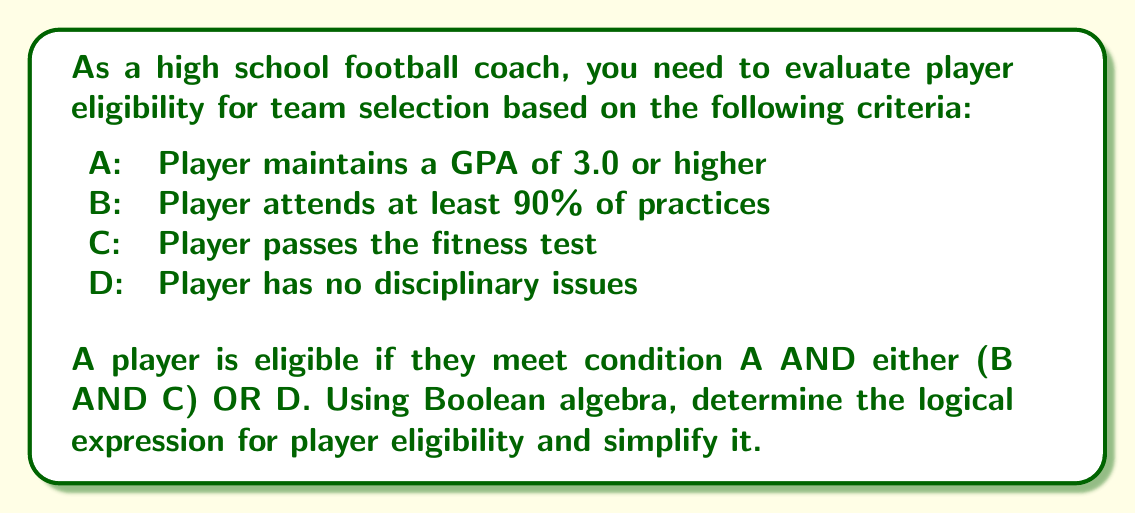Teach me how to tackle this problem. Let's approach this step-by-step:

1) First, let's write out the logical expression based on the given conditions:

   $E = A \wedge ((B \wedge C) \vee D)$

   Where E represents eligibility, and $\wedge$ means AND, $\vee$ means OR.

2) To simplify this expression, we can use the distributive law of Boolean algebra:

   $X \wedge (Y \vee Z) = (X \wedge Y) \vee (X \wedge Z)$

3) Applying this to our expression:

   $E = A \wedge ((B \wedge C) \vee D)$
   $E = (A \wedge (B \wedge C)) \vee (A \wedge D)$

4) Using the associative law of AND:

   $E = ((A \wedge B) \wedge C) \vee (A \wedge D)$

5) This is the simplified form of the expression. It means a player is eligible if:
   - They have a GPA of 3.0 or higher AND attend 90% of practices AND pass the fitness test, OR
   - They have a GPA of 3.0 or higher AND have no disciplinary issues

This simplified form allows for easier evaluation of player eligibility.
Answer: $E = ((A \wedge B) \wedge C) \vee (A \wedge D)$ 